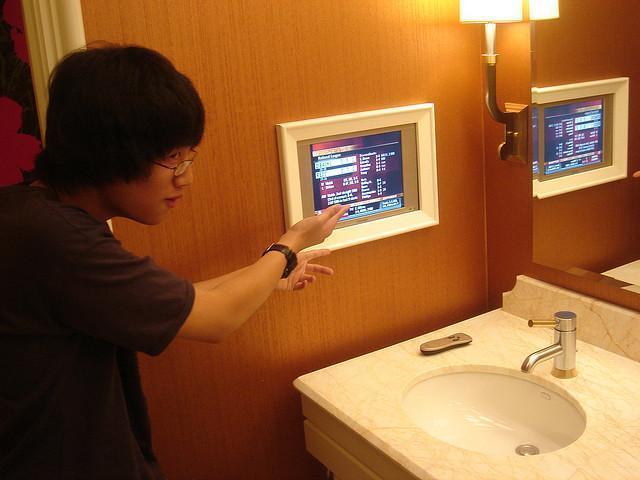How many tvs are there?
Give a very brief answer. 2. 